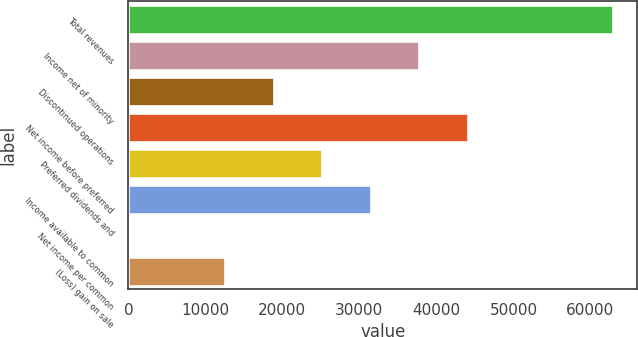Convert chart to OTSL. <chart><loc_0><loc_0><loc_500><loc_500><bar_chart><fcel>Total revenues<fcel>Income net of minority<fcel>Discontinued operations<fcel>Net income before preferred<fcel>Preferred dividends and<fcel>Income available to common<fcel>Net income per common<fcel>(Loss) gain on sale<nl><fcel>62949<fcel>37769.6<fcel>18885.1<fcel>44064.5<fcel>25179.9<fcel>31474.8<fcel>0.54<fcel>12590.2<nl></chart> 